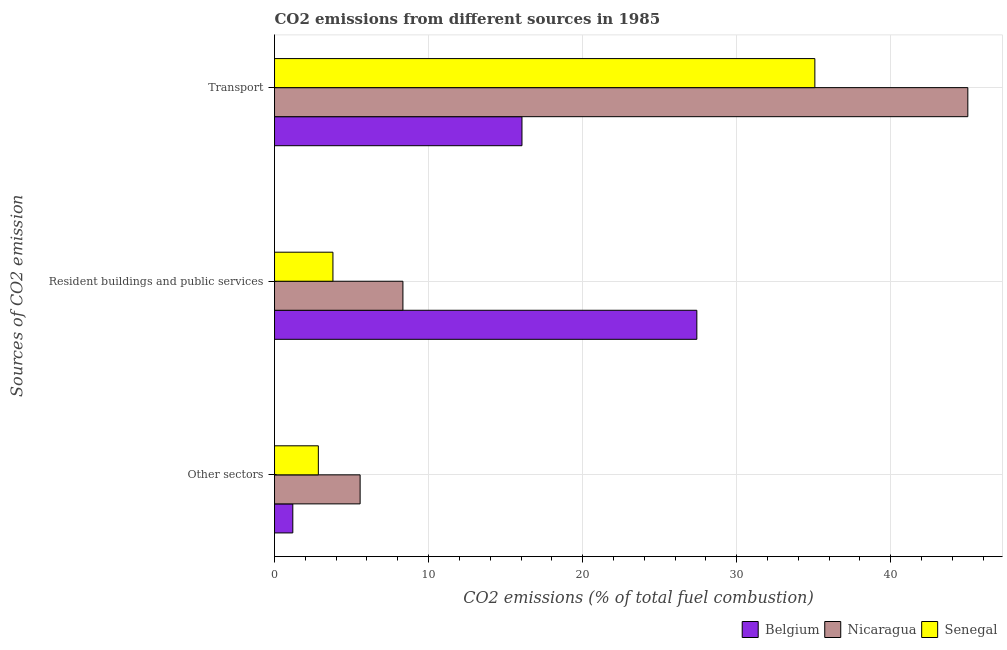Are the number of bars on each tick of the Y-axis equal?
Provide a succinct answer. Yes. How many bars are there on the 2nd tick from the top?
Offer a terse response. 3. What is the label of the 3rd group of bars from the top?
Make the answer very short. Other sectors. What is the percentage of co2 emissions from resident buildings and public services in Nicaragua?
Provide a short and direct response. 8.33. Across all countries, what is the maximum percentage of co2 emissions from other sectors?
Your response must be concise. 5.56. Across all countries, what is the minimum percentage of co2 emissions from resident buildings and public services?
Your response must be concise. 3.79. In which country was the percentage of co2 emissions from other sectors maximum?
Your response must be concise. Nicaragua. What is the total percentage of co2 emissions from other sectors in the graph?
Make the answer very short. 9.59. What is the difference between the percentage of co2 emissions from resident buildings and public services in Belgium and that in Senegal?
Ensure brevity in your answer.  23.62. What is the difference between the percentage of co2 emissions from other sectors in Senegal and the percentage of co2 emissions from transport in Nicaragua?
Provide a succinct answer. -42.16. What is the average percentage of co2 emissions from transport per country?
Your answer should be compact. 32.04. What is the difference between the percentage of co2 emissions from other sectors and percentage of co2 emissions from transport in Belgium?
Provide a succinct answer. -14.87. What is the ratio of the percentage of co2 emissions from other sectors in Senegal to that in Belgium?
Provide a short and direct response. 2.4. Is the difference between the percentage of co2 emissions from resident buildings and public services in Nicaragua and Senegal greater than the difference between the percentage of co2 emissions from other sectors in Nicaragua and Senegal?
Provide a succinct answer. Yes. What is the difference between the highest and the second highest percentage of co2 emissions from other sectors?
Offer a terse response. 2.71. What is the difference between the highest and the lowest percentage of co2 emissions from other sectors?
Keep it short and to the point. 4.37. In how many countries, is the percentage of co2 emissions from resident buildings and public services greater than the average percentage of co2 emissions from resident buildings and public services taken over all countries?
Your response must be concise. 1. What does the 2nd bar from the bottom in Resident buildings and public services represents?
Make the answer very short. Nicaragua. Is it the case that in every country, the sum of the percentage of co2 emissions from other sectors and percentage of co2 emissions from resident buildings and public services is greater than the percentage of co2 emissions from transport?
Make the answer very short. No. How many bars are there?
Offer a terse response. 9. How many countries are there in the graph?
Ensure brevity in your answer.  3. Does the graph contain grids?
Provide a succinct answer. Yes. What is the title of the graph?
Your answer should be very brief. CO2 emissions from different sources in 1985. What is the label or title of the X-axis?
Ensure brevity in your answer.  CO2 emissions (% of total fuel combustion). What is the label or title of the Y-axis?
Keep it short and to the point. Sources of CO2 emission. What is the CO2 emissions (% of total fuel combustion) in Belgium in Other sectors?
Provide a short and direct response. 1.19. What is the CO2 emissions (% of total fuel combustion) in Nicaragua in Other sectors?
Give a very brief answer. 5.56. What is the CO2 emissions (% of total fuel combustion) of Senegal in Other sectors?
Offer a terse response. 2.84. What is the CO2 emissions (% of total fuel combustion) of Belgium in Resident buildings and public services?
Make the answer very short. 27.41. What is the CO2 emissions (% of total fuel combustion) in Nicaragua in Resident buildings and public services?
Offer a very short reply. 8.33. What is the CO2 emissions (% of total fuel combustion) in Senegal in Resident buildings and public services?
Offer a terse response. 3.79. What is the CO2 emissions (% of total fuel combustion) in Belgium in Transport?
Your answer should be compact. 16.06. What is the CO2 emissions (% of total fuel combustion) of Nicaragua in Transport?
Make the answer very short. 45. What is the CO2 emissions (% of total fuel combustion) of Senegal in Transport?
Provide a succinct answer. 35.07. Across all Sources of CO2 emission, what is the maximum CO2 emissions (% of total fuel combustion) in Belgium?
Your answer should be very brief. 27.41. Across all Sources of CO2 emission, what is the maximum CO2 emissions (% of total fuel combustion) in Nicaragua?
Give a very brief answer. 45. Across all Sources of CO2 emission, what is the maximum CO2 emissions (% of total fuel combustion) in Senegal?
Ensure brevity in your answer.  35.07. Across all Sources of CO2 emission, what is the minimum CO2 emissions (% of total fuel combustion) of Belgium?
Your response must be concise. 1.19. Across all Sources of CO2 emission, what is the minimum CO2 emissions (% of total fuel combustion) of Nicaragua?
Your answer should be very brief. 5.56. Across all Sources of CO2 emission, what is the minimum CO2 emissions (% of total fuel combustion) of Senegal?
Ensure brevity in your answer.  2.84. What is the total CO2 emissions (% of total fuel combustion) of Belgium in the graph?
Make the answer very short. 44.66. What is the total CO2 emissions (% of total fuel combustion) of Nicaragua in the graph?
Offer a terse response. 58.89. What is the total CO2 emissions (% of total fuel combustion) of Senegal in the graph?
Your answer should be very brief. 41.71. What is the difference between the CO2 emissions (% of total fuel combustion) of Belgium in Other sectors and that in Resident buildings and public services?
Provide a succinct answer. -26.22. What is the difference between the CO2 emissions (% of total fuel combustion) in Nicaragua in Other sectors and that in Resident buildings and public services?
Offer a terse response. -2.78. What is the difference between the CO2 emissions (% of total fuel combustion) of Senegal in Other sectors and that in Resident buildings and public services?
Offer a terse response. -0.95. What is the difference between the CO2 emissions (% of total fuel combustion) of Belgium in Other sectors and that in Transport?
Keep it short and to the point. -14.87. What is the difference between the CO2 emissions (% of total fuel combustion) in Nicaragua in Other sectors and that in Transport?
Keep it short and to the point. -39.44. What is the difference between the CO2 emissions (% of total fuel combustion) of Senegal in Other sectors and that in Transport?
Your response must be concise. -32.23. What is the difference between the CO2 emissions (% of total fuel combustion) of Belgium in Resident buildings and public services and that in Transport?
Offer a terse response. 11.35. What is the difference between the CO2 emissions (% of total fuel combustion) in Nicaragua in Resident buildings and public services and that in Transport?
Provide a short and direct response. -36.67. What is the difference between the CO2 emissions (% of total fuel combustion) in Senegal in Resident buildings and public services and that in Transport?
Provide a succinct answer. -31.28. What is the difference between the CO2 emissions (% of total fuel combustion) in Belgium in Other sectors and the CO2 emissions (% of total fuel combustion) in Nicaragua in Resident buildings and public services?
Your answer should be very brief. -7.15. What is the difference between the CO2 emissions (% of total fuel combustion) in Belgium in Other sectors and the CO2 emissions (% of total fuel combustion) in Senegal in Resident buildings and public services?
Keep it short and to the point. -2.6. What is the difference between the CO2 emissions (% of total fuel combustion) in Nicaragua in Other sectors and the CO2 emissions (% of total fuel combustion) in Senegal in Resident buildings and public services?
Offer a very short reply. 1.76. What is the difference between the CO2 emissions (% of total fuel combustion) in Belgium in Other sectors and the CO2 emissions (% of total fuel combustion) in Nicaragua in Transport?
Provide a succinct answer. -43.81. What is the difference between the CO2 emissions (% of total fuel combustion) in Belgium in Other sectors and the CO2 emissions (% of total fuel combustion) in Senegal in Transport?
Ensure brevity in your answer.  -33.88. What is the difference between the CO2 emissions (% of total fuel combustion) in Nicaragua in Other sectors and the CO2 emissions (% of total fuel combustion) in Senegal in Transport?
Offer a very short reply. -29.52. What is the difference between the CO2 emissions (% of total fuel combustion) in Belgium in Resident buildings and public services and the CO2 emissions (% of total fuel combustion) in Nicaragua in Transport?
Provide a succinct answer. -17.59. What is the difference between the CO2 emissions (% of total fuel combustion) of Belgium in Resident buildings and public services and the CO2 emissions (% of total fuel combustion) of Senegal in Transport?
Your answer should be very brief. -7.66. What is the difference between the CO2 emissions (% of total fuel combustion) in Nicaragua in Resident buildings and public services and the CO2 emissions (% of total fuel combustion) in Senegal in Transport?
Make the answer very short. -26.74. What is the average CO2 emissions (% of total fuel combustion) in Belgium per Sources of CO2 emission?
Provide a succinct answer. 14.89. What is the average CO2 emissions (% of total fuel combustion) of Nicaragua per Sources of CO2 emission?
Offer a very short reply. 19.63. What is the average CO2 emissions (% of total fuel combustion) of Senegal per Sources of CO2 emission?
Offer a terse response. 13.9. What is the difference between the CO2 emissions (% of total fuel combustion) of Belgium and CO2 emissions (% of total fuel combustion) of Nicaragua in Other sectors?
Your response must be concise. -4.37. What is the difference between the CO2 emissions (% of total fuel combustion) of Belgium and CO2 emissions (% of total fuel combustion) of Senegal in Other sectors?
Your answer should be very brief. -1.66. What is the difference between the CO2 emissions (% of total fuel combustion) in Nicaragua and CO2 emissions (% of total fuel combustion) in Senegal in Other sectors?
Give a very brief answer. 2.71. What is the difference between the CO2 emissions (% of total fuel combustion) in Belgium and CO2 emissions (% of total fuel combustion) in Nicaragua in Resident buildings and public services?
Ensure brevity in your answer.  19.08. What is the difference between the CO2 emissions (% of total fuel combustion) in Belgium and CO2 emissions (% of total fuel combustion) in Senegal in Resident buildings and public services?
Your answer should be compact. 23.62. What is the difference between the CO2 emissions (% of total fuel combustion) of Nicaragua and CO2 emissions (% of total fuel combustion) of Senegal in Resident buildings and public services?
Make the answer very short. 4.54. What is the difference between the CO2 emissions (% of total fuel combustion) of Belgium and CO2 emissions (% of total fuel combustion) of Nicaragua in Transport?
Provide a short and direct response. -28.94. What is the difference between the CO2 emissions (% of total fuel combustion) of Belgium and CO2 emissions (% of total fuel combustion) of Senegal in Transport?
Provide a short and direct response. -19.01. What is the difference between the CO2 emissions (% of total fuel combustion) in Nicaragua and CO2 emissions (% of total fuel combustion) in Senegal in Transport?
Your answer should be very brief. 9.93. What is the ratio of the CO2 emissions (% of total fuel combustion) in Belgium in Other sectors to that in Resident buildings and public services?
Provide a short and direct response. 0.04. What is the ratio of the CO2 emissions (% of total fuel combustion) in Belgium in Other sectors to that in Transport?
Provide a succinct answer. 0.07. What is the ratio of the CO2 emissions (% of total fuel combustion) of Nicaragua in Other sectors to that in Transport?
Give a very brief answer. 0.12. What is the ratio of the CO2 emissions (% of total fuel combustion) in Senegal in Other sectors to that in Transport?
Offer a very short reply. 0.08. What is the ratio of the CO2 emissions (% of total fuel combustion) in Belgium in Resident buildings and public services to that in Transport?
Provide a short and direct response. 1.71. What is the ratio of the CO2 emissions (% of total fuel combustion) in Nicaragua in Resident buildings and public services to that in Transport?
Provide a succinct answer. 0.19. What is the ratio of the CO2 emissions (% of total fuel combustion) in Senegal in Resident buildings and public services to that in Transport?
Provide a succinct answer. 0.11. What is the difference between the highest and the second highest CO2 emissions (% of total fuel combustion) of Belgium?
Provide a short and direct response. 11.35. What is the difference between the highest and the second highest CO2 emissions (% of total fuel combustion) in Nicaragua?
Keep it short and to the point. 36.67. What is the difference between the highest and the second highest CO2 emissions (% of total fuel combustion) in Senegal?
Make the answer very short. 31.28. What is the difference between the highest and the lowest CO2 emissions (% of total fuel combustion) of Belgium?
Give a very brief answer. 26.22. What is the difference between the highest and the lowest CO2 emissions (% of total fuel combustion) of Nicaragua?
Provide a short and direct response. 39.44. What is the difference between the highest and the lowest CO2 emissions (% of total fuel combustion) of Senegal?
Offer a terse response. 32.23. 